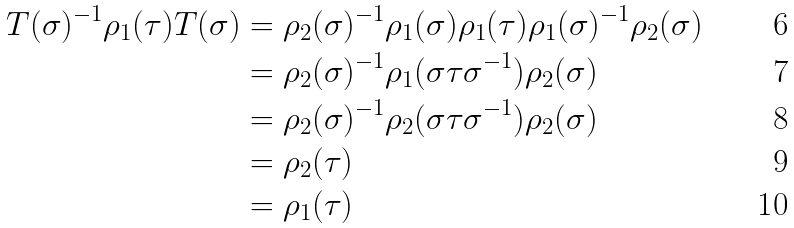<formula> <loc_0><loc_0><loc_500><loc_500>T ( \sigma ) ^ { - 1 } \rho _ { 1 } ( \tau ) T ( \sigma ) & = \rho _ { 2 } ( \sigma ) ^ { - 1 } \rho _ { 1 } ( \sigma ) \rho _ { 1 } ( \tau ) \rho _ { 1 } ( \sigma ) ^ { - 1 } \rho _ { 2 } ( \sigma ) \\ & = \rho _ { 2 } ( \sigma ) ^ { - 1 } \rho _ { 1 } ( \sigma \tau \sigma ^ { - 1 } ) \rho _ { 2 } ( \sigma ) \\ & = \rho _ { 2 } ( \sigma ) ^ { - 1 } \rho _ { 2 } ( \sigma \tau \sigma ^ { - 1 } ) \rho _ { 2 } ( \sigma ) \\ & = \rho _ { 2 } ( \tau ) \\ & = \rho _ { 1 } ( \tau )</formula> 